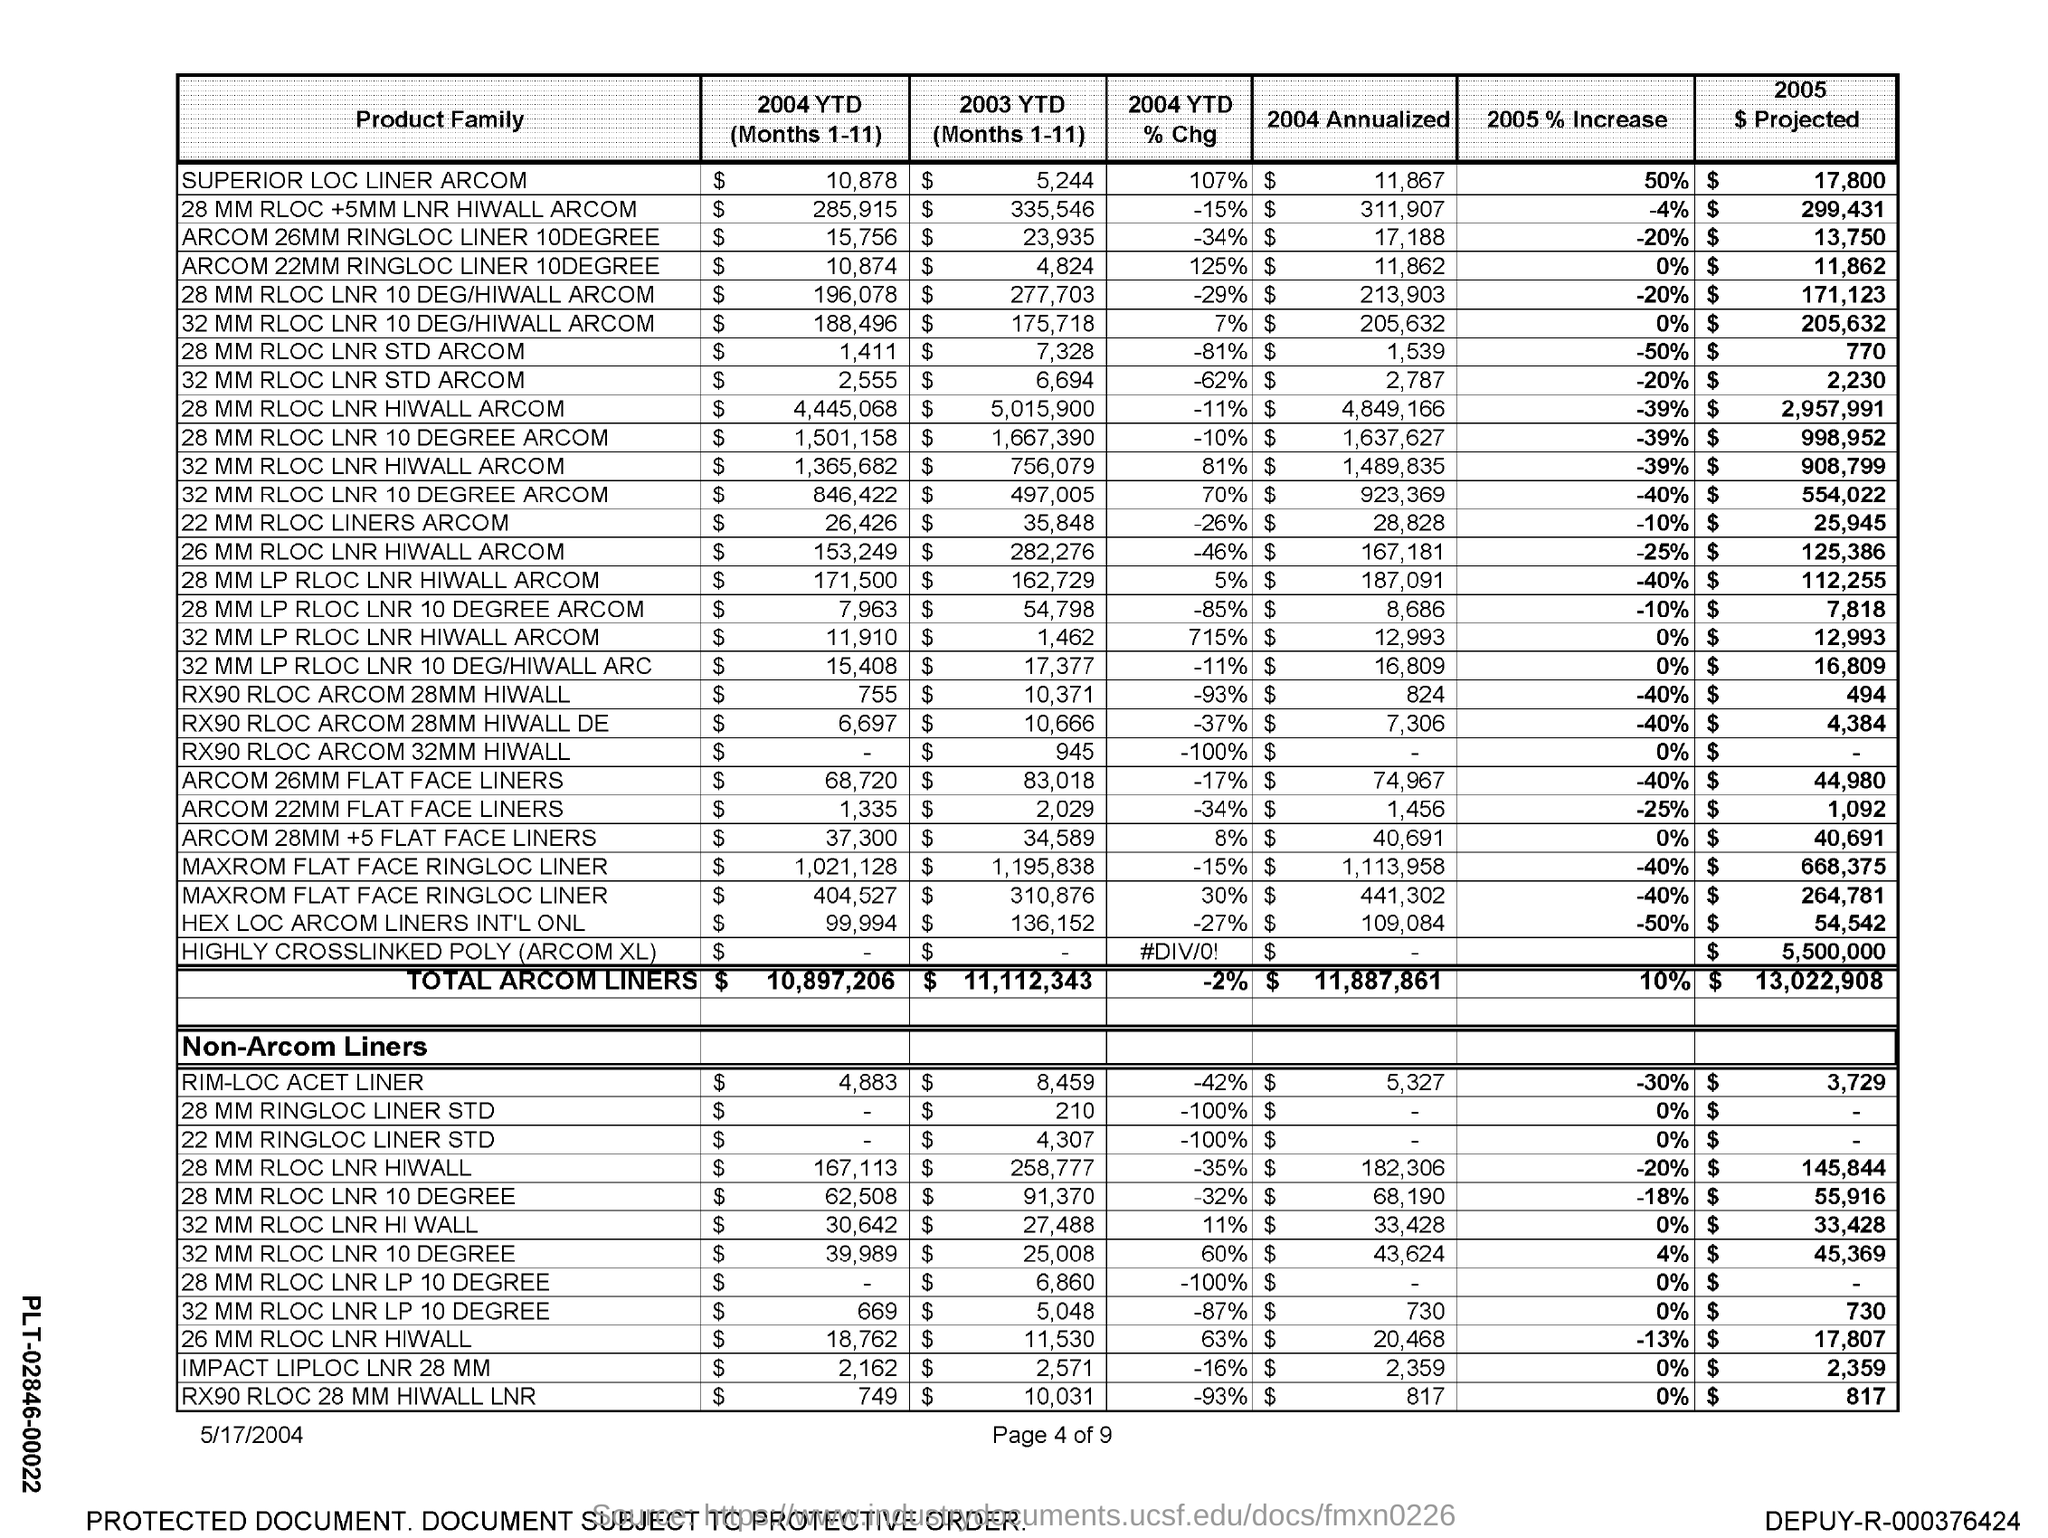What is the 2004 YTD (Months 1-11) for Superior LOC Liner ARCOM?
Keep it short and to the point. $ 10,878. What is the 2003 YTD (Months 1-11) for Superior LOC Liner ARCOM?
Your answer should be compact. $5,244. What is the 2004 YTD % Chg for Superior LOC Liner ARCOM?
Provide a short and direct response. 107%. What is the 2004 Annualized for Superior LOC Liner ARCOM?
Your answer should be very brief. $ 11,867. What is the total ARCOM Liners for 2004 YTD (Months 1-11)?
Provide a succinct answer. $10,897,206. What is the total ARCOM Liners for 2003 YTD (Months 1-11)?
Provide a succinct answer. $ 11,112,343. What is the total ARCOM Liners for 2004 YTD % Chg?
Ensure brevity in your answer.  -2%. What is the total ARCOM Liners for 2004 Annaulized?
Your response must be concise. $11,887,861. 